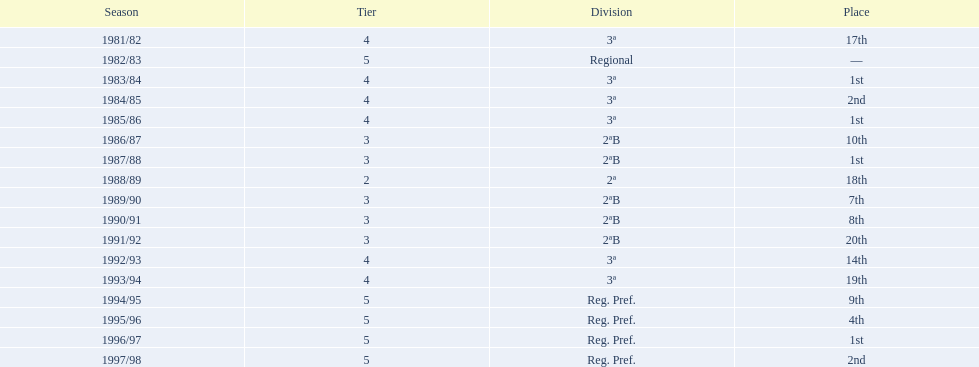In how many instances did they achieve the first place finish? 4. 